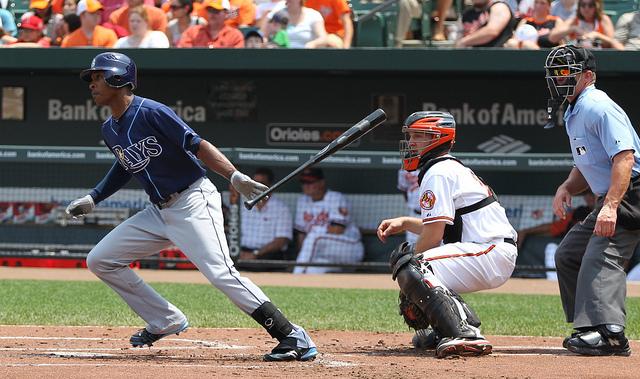Is the bat broken?
Write a very short answer. No. Has the batter swung the bat?
Be succinct. Yes. What is the man in the gray pants wearing on his face?
Quick response, please. Mask. What is the man about to do?
Short answer required. Run. Is he holding the bat?
Answer briefly. No. 